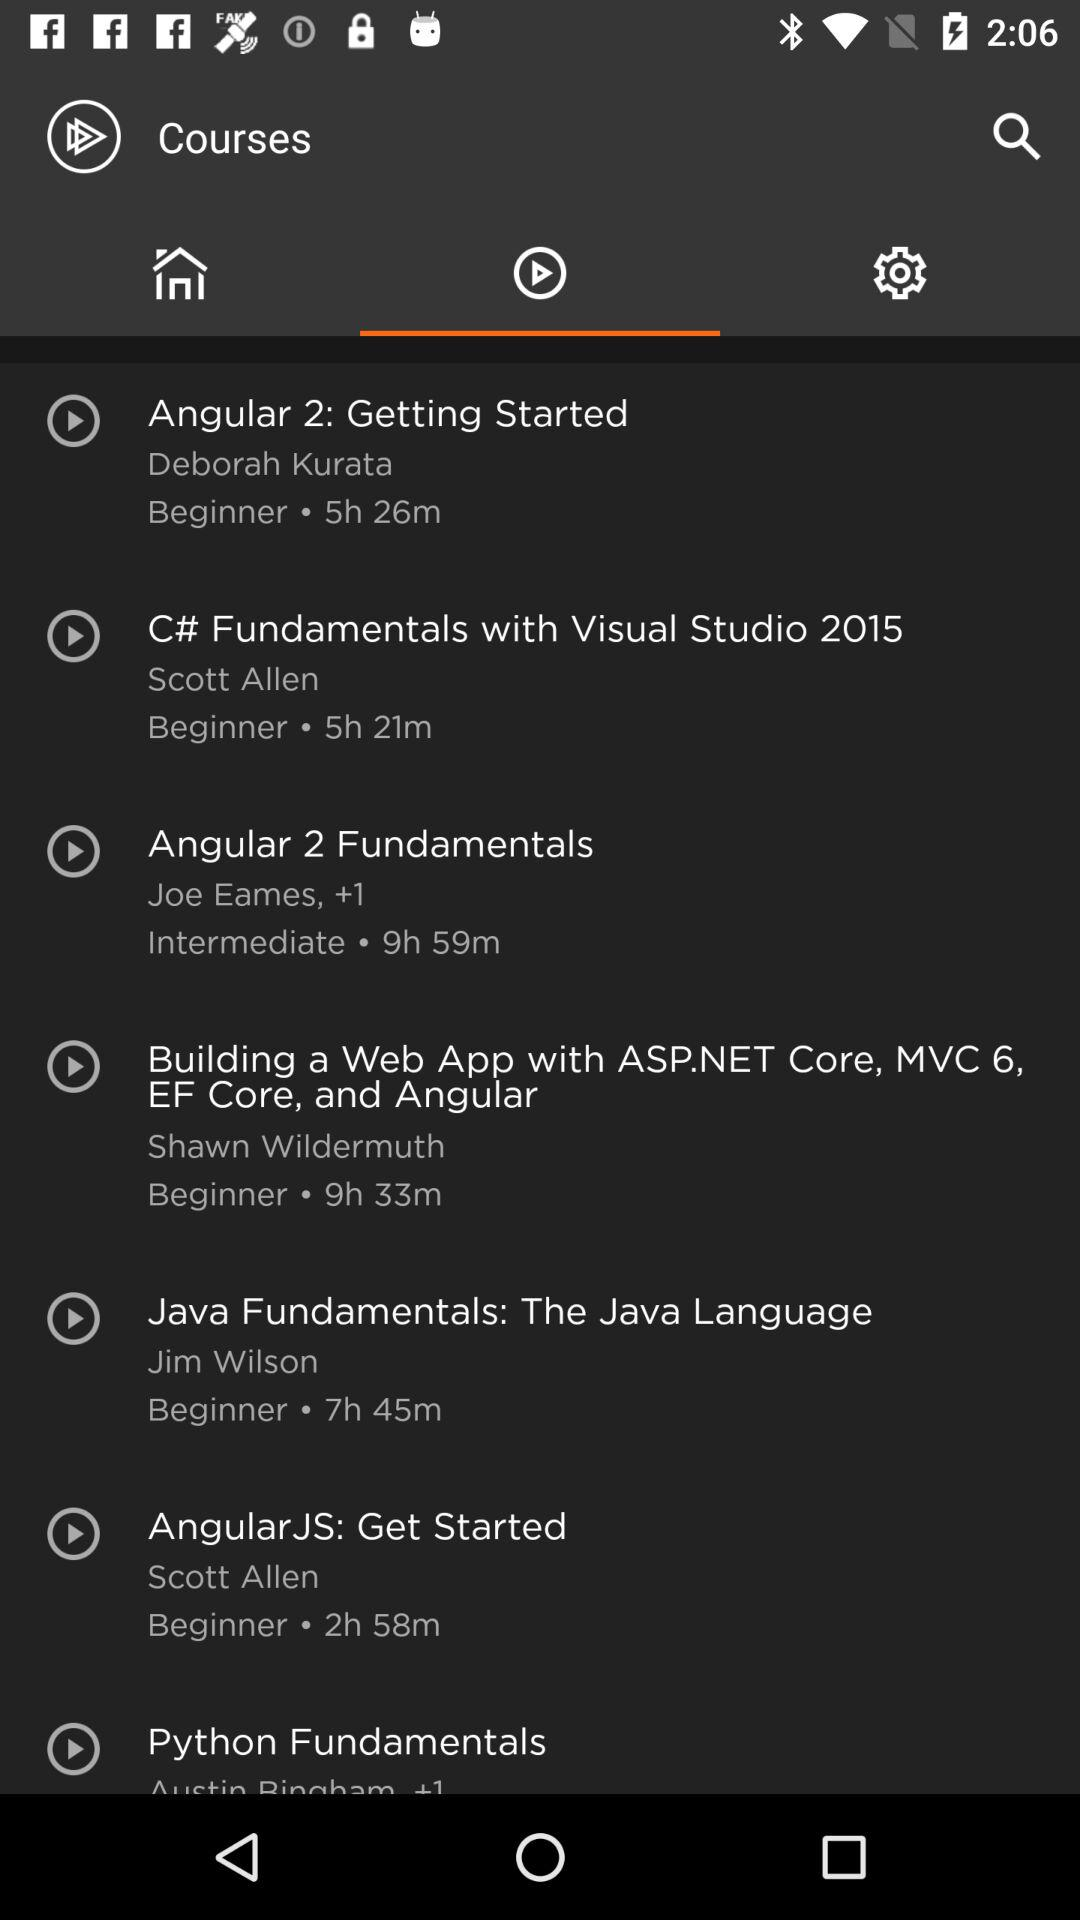What is the duration of the Java Fundamentals course? The duration of the Java Fundamentals course is 7 hours and 45 minutes. 